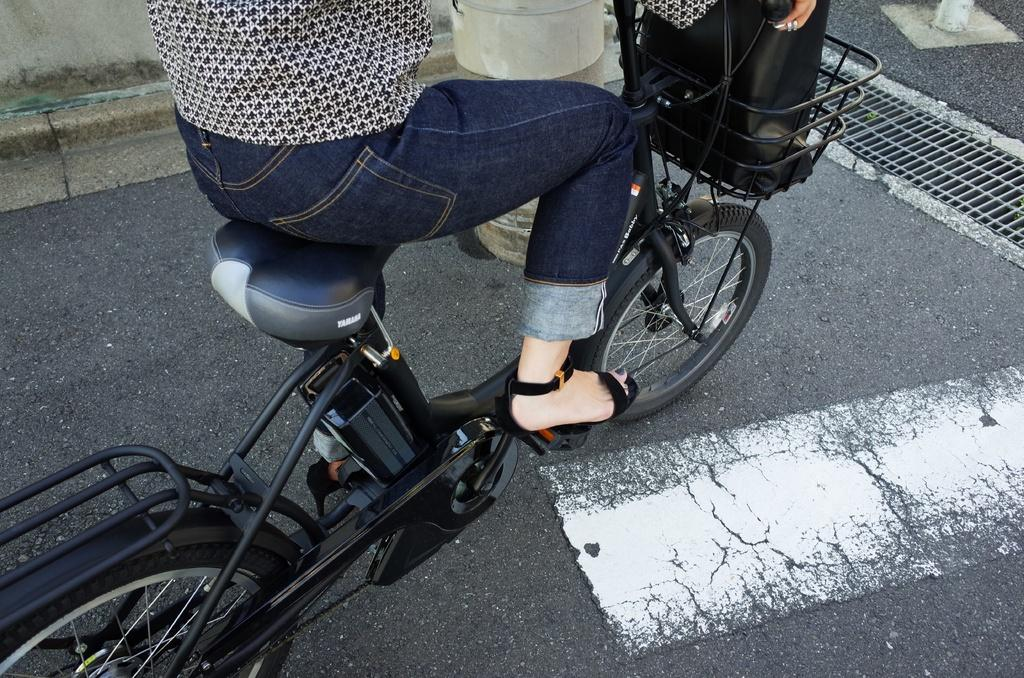What is the person in the image doing? There is a person riding a bicycle in the image. What is in the basket of the bicycle? There is a bag in the basket of the bicycle. What is the bag made of? The bag appears to be made of cloth. What can be seen in the background of the image? There is a wall visible in the image. Can you hear a whistle in the image? There is no mention of a whistle in the image, so it cannot be heard. 